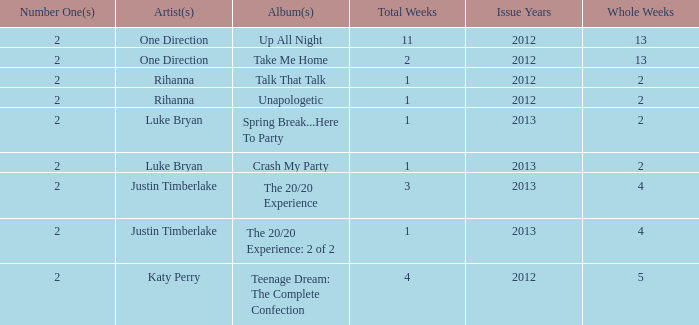What is the longest number of weeks any 1 song was at number #1? 13.0. 